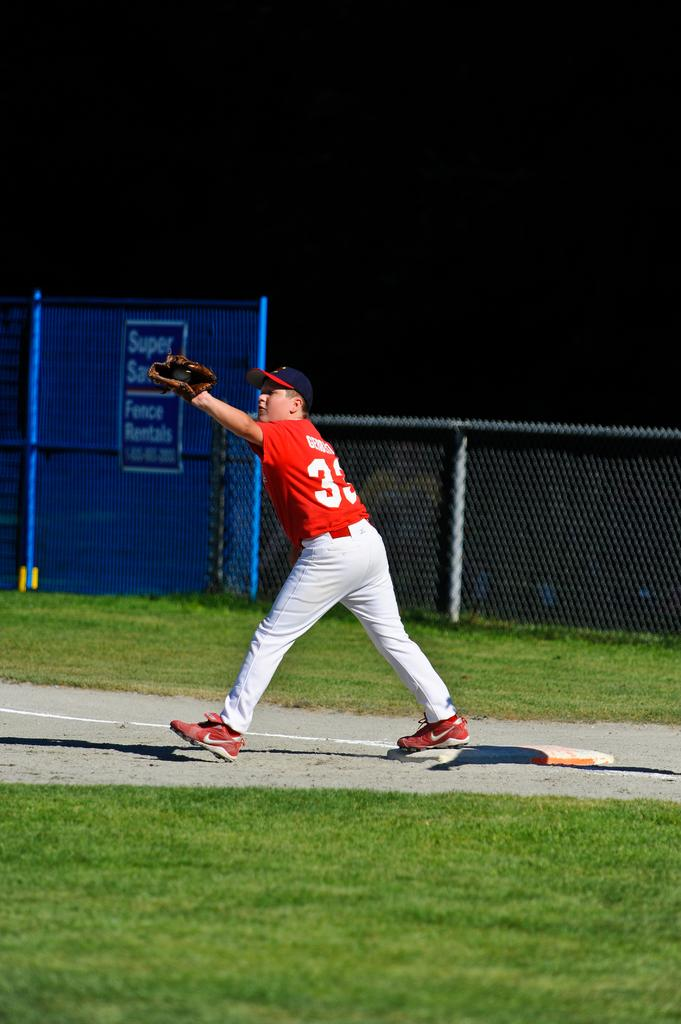<image>
Summarize the visual content of the image. a baseball player on the bag with number  33 and Super on the fence 